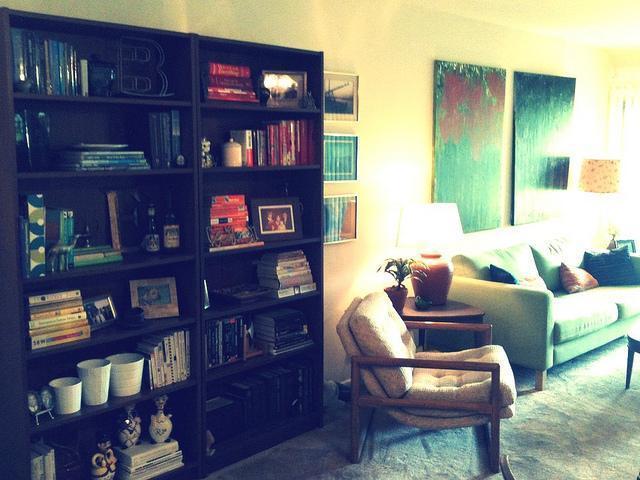How many books are visible?
Give a very brief answer. 2. How many chairs are there?
Give a very brief answer. 1. 